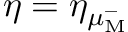<formula> <loc_0><loc_0><loc_500><loc_500>\eta = \eta _ { \mu _ { M } ^ { - } }</formula> 